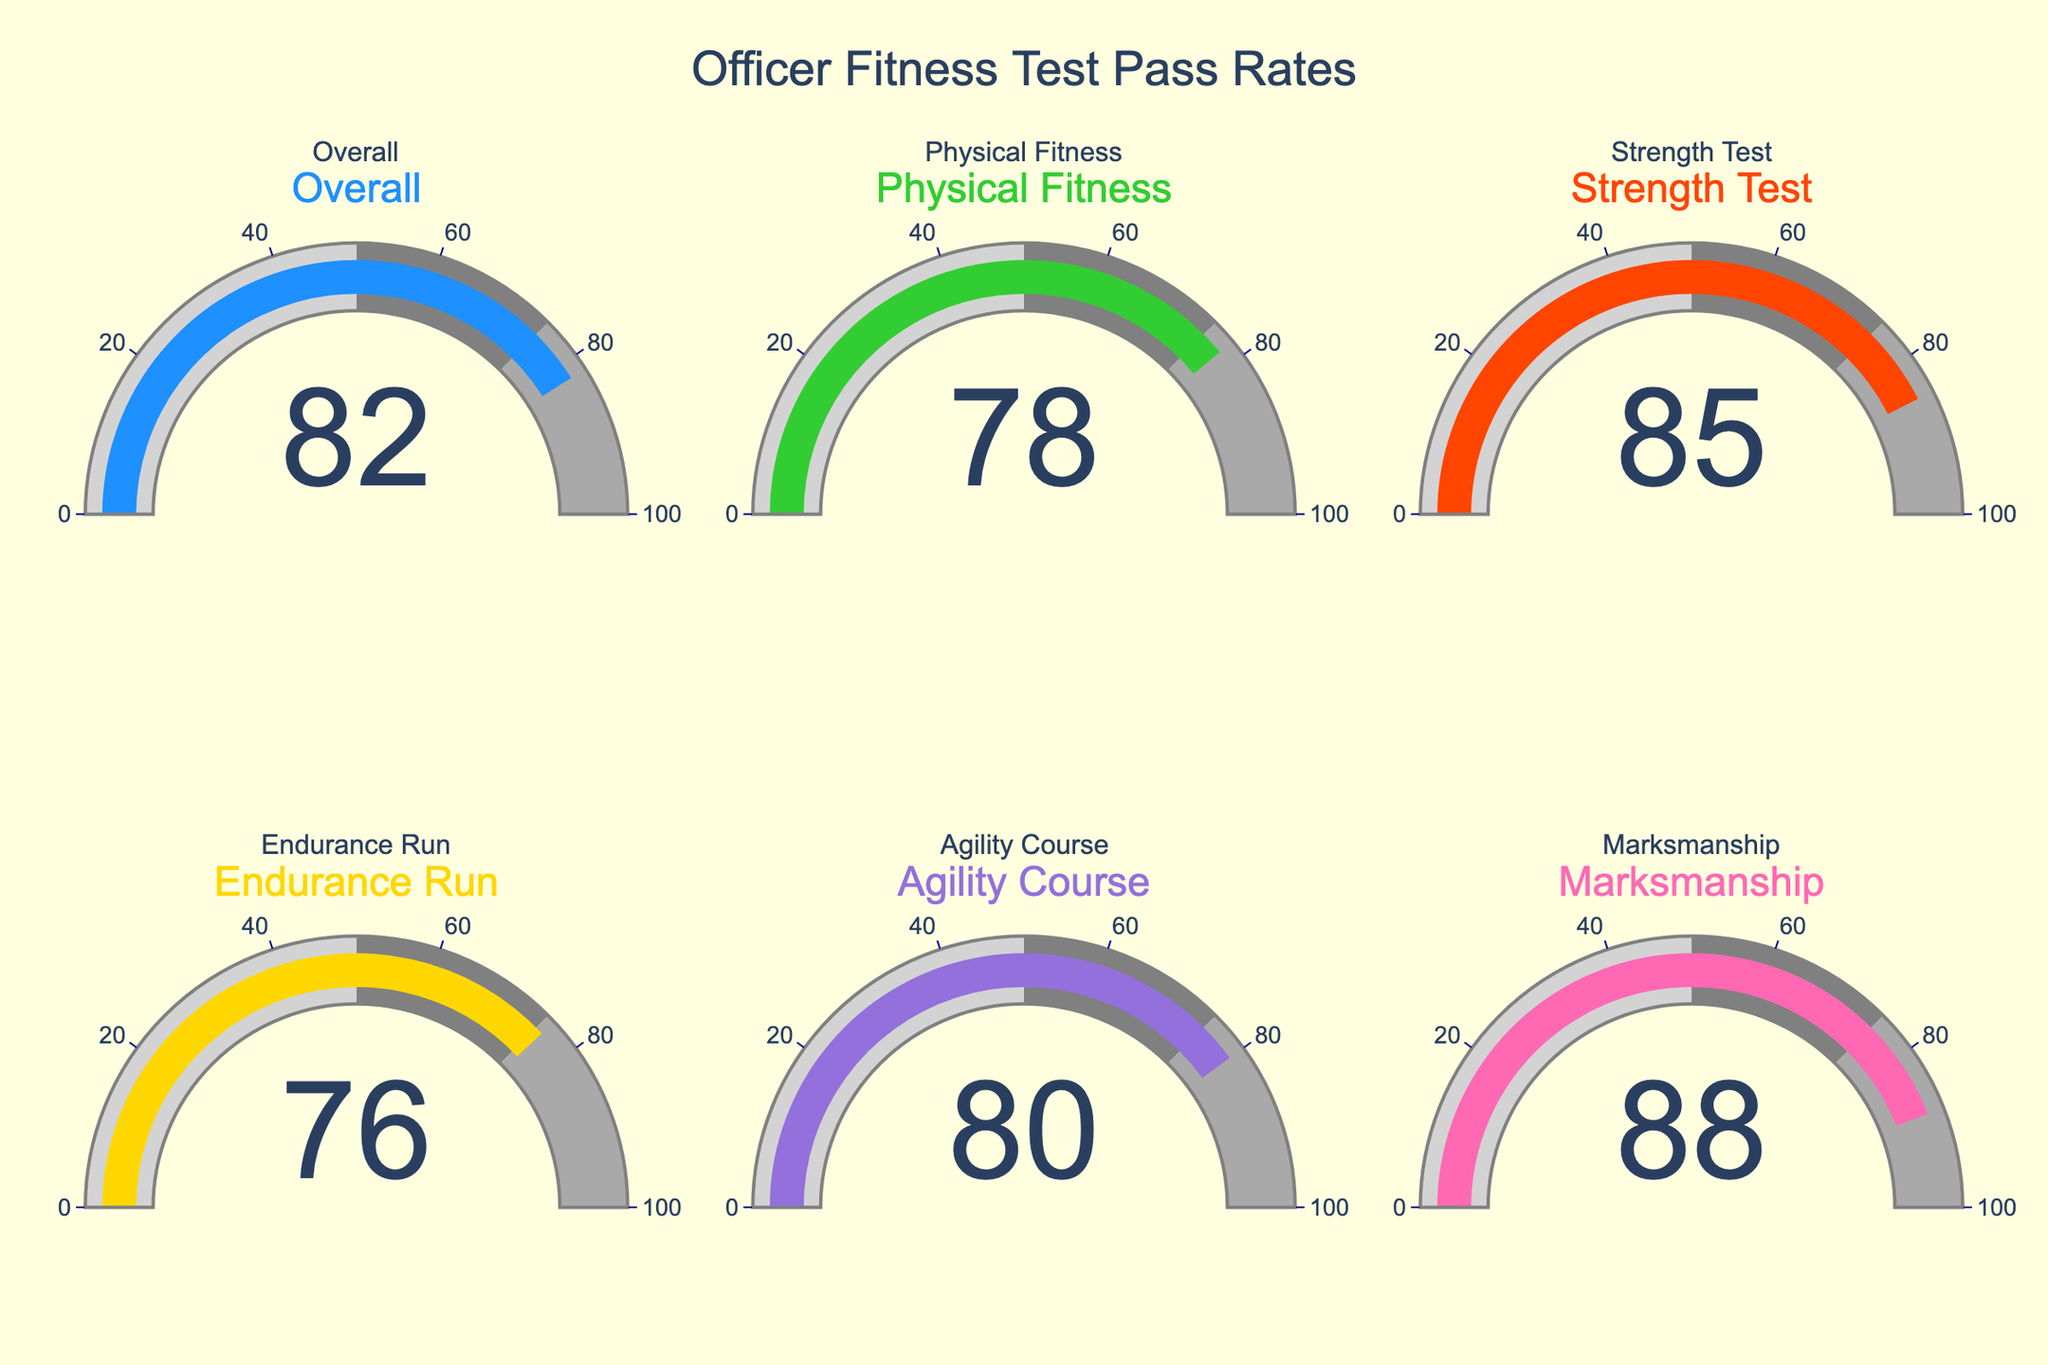What is the overall pass rate for the Officer Fitness Test? The overall pass rate is directly shown in the gauge for "Overall."
Answer: 82 What is the pass rate for the Endurance Run? The pass rate for the Endurance Run is displayed in the corresponding gauge for that category.
Answer: 76 Which test has the highest pass rate? The test with the highest pass rate can be identified by comparing the values shown in each gauge. Marksmanship has the highest value.
Answer: Marksmanship Which test has the lowest pass rate? The test with the lowest pass rate can be identified by comparing the values shown in each gauge. Endurance Run has the lowest value.
Answer: Endurance Run What is the difference in pass rates between the Physical Fitness test and the Strength Test? Subtract the pass rate for Physical Fitness from the pass rate for the Strength Test: 85 - 78 = 7
Answer: 7 What is the average pass rate for the Agility Course and the Strength Test? Add the pass rates for Agility Course and Strength Test, then divide by 2: (80 + 85) / 2 = 82.5
Answer: 82.5 Are any tests' pass rates below 80? Compare the pass rates shown in the gauges to 80. Physical Fitness and Endurance Run are below 80.
Answer: Yes Which tests have pass rates within the range of 75 to 85? Check the gauges to see which pass rates fall between 75 and 85. These are: Physical Fitness, Endurance Run, Agility Course, and Strength Test.
Answer: Physical Fitness, Endurance Run, Agility Course, Strength Test Is the marksmanship pass rate closer to 75 or 100? Compare the marksmanship pass rate of 88 to the midpoint of the range (87.5): 88 is closer to 100.
Answer: 100 What is the median pass rate among all tests? Arrange the pass rates (82, 78, 85, 76, 80, 88) in ascending order and find the middle value. For an even number of data points, the median is the average of the two middle values. (78, 76, 80, 82, 85, 88) → Median is (80 + 82) / 2 = 81
Answer: 81 